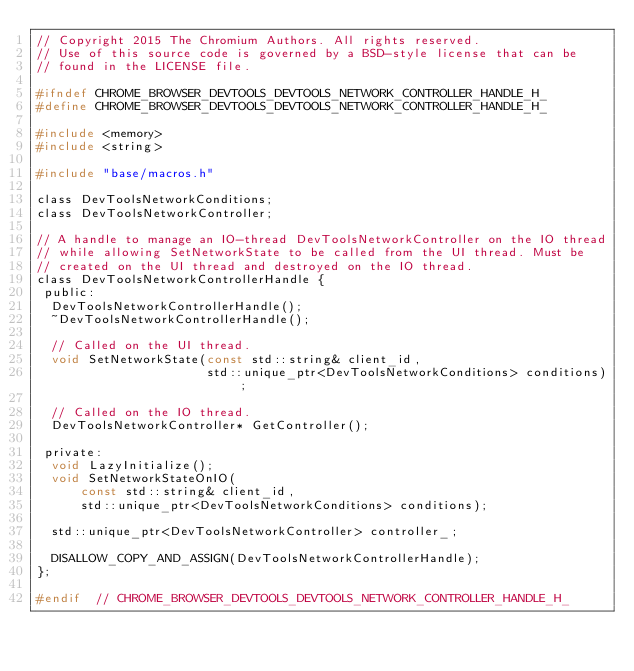Convert code to text. <code><loc_0><loc_0><loc_500><loc_500><_C_>// Copyright 2015 The Chromium Authors. All rights reserved.
// Use of this source code is governed by a BSD-style license that can be
// found in the LICENSE file.

#ifndef CHROME_BROWSER_DEVTOOLS_DEVTOOLS_NETWORK_CONTROLLER_HANDLE_H_
#define CHROME_BROWSER_DEVTOOLS_DEVTOOLS_NETWORK_CONTROLLER_HANDLE_H_

#include <memory>
#include <string>

#include "base/macros.h"

class DevToolsNetworkConditions;
class DevToolsNetworkController;

// A handle to manage an IO-thread DevToolsNetworkController on the IO thread
// while allowing SetNetworkState to be called from the UI thread. Must be
// created on the UI thread and destroyed on the IO thread.
class DevToolsNetworkControllerHandle {
 public:
  DevToolsNetworkControllerHandle();
  ~DevToolsNetworkControllerHandle();

  // Called on the UI thread.
  void SetNetworkState(const std::string& client_id,
                       std::unique_ptr<DevToolsNetworkConditions> conditions);

  // Called on the IO thread.
  DevToolsNetworkController* GetController();

 private:
  void LazyInitialize();
  void SetNetworkStateOnIO(
      const std::string& client_id,
      std::unique_ptr<DevToolsNetworkConditions> conditions);

  std::unique_ptr<DevToolsNetworkController> controller_;

  DISALLOW_COPY_AND_ASSIGN(DevToolsNetworkControllerHandle);
};

#endif  // CHROME_BROWSER_DEVTOOLS_DEVTOOLS_NETWORK_CONTROLLER_HANDLE_H_
</code> 